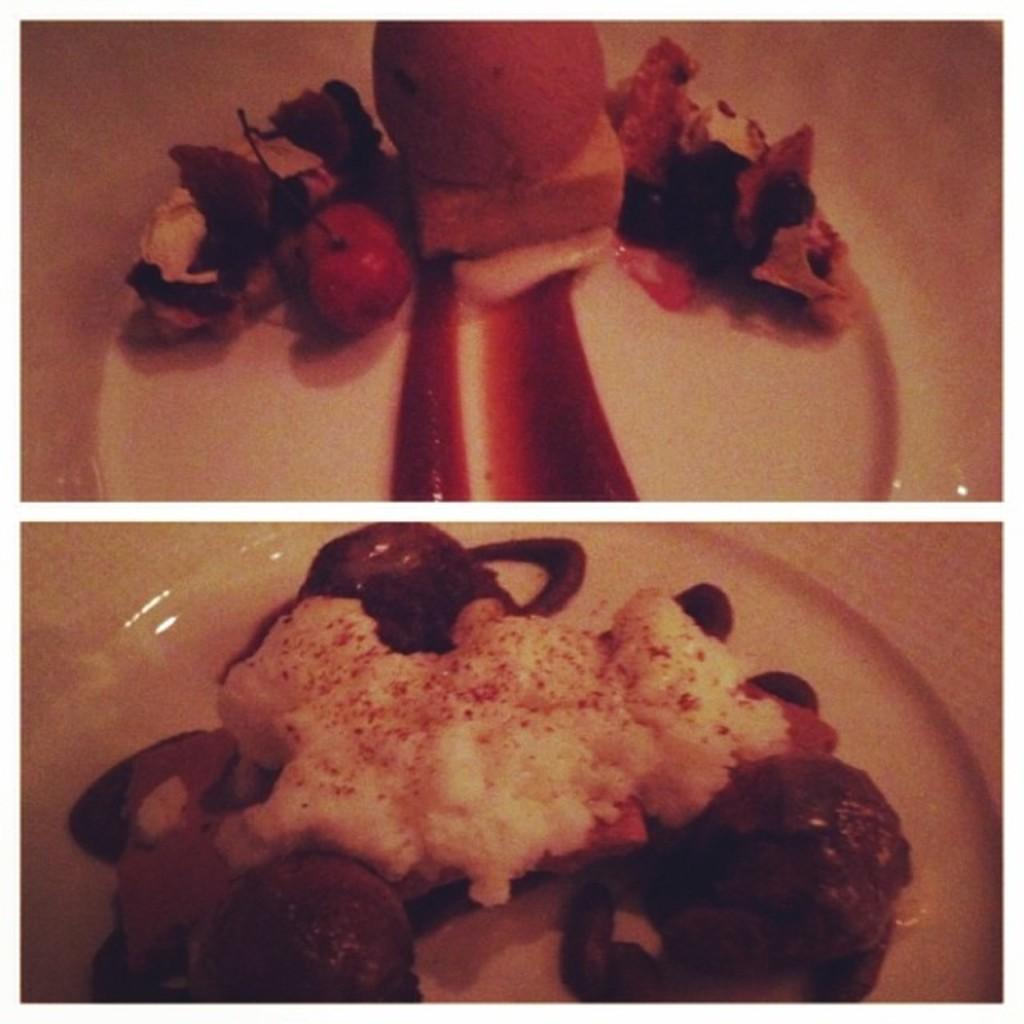Please provide a concise description of this image. In the image we can see the collage photos, in it we can see the plate and on the plate there is a food item. 